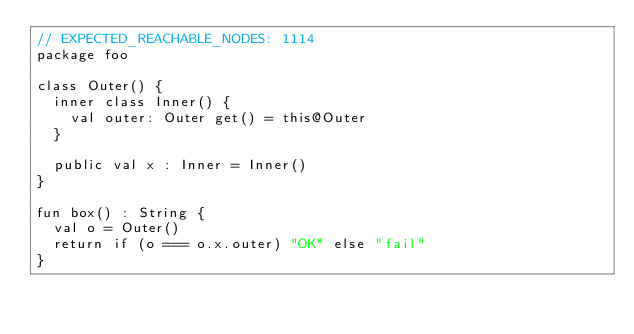<code> <loc_0><loc_0><loc_500><loc_500><_Kotlin_>// EXPECTED_REACHABLE_NODES: 1114
package foo

class Outer() {
  inner class Inner() {
    val outer: Outer get() = this@Outer
  }

  public val x : Inner = Inner()
}

fun box() : String {
  val o = Outer()
  return if (o === o.x.outer) "OK" else "fail"
}
</code> 